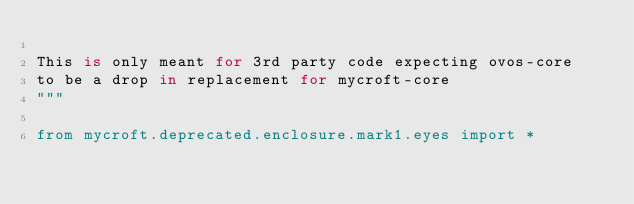Convert code to text. <code><loc_0><loc_0><loc_500><loc_500><_Python_>
This is only meant for 3rd party code expecting ovos-core
to be a drop in replacement for mycroft-core
"""

from mycroft.deprecated.enclosure.mark1.eyes import *
</code> 